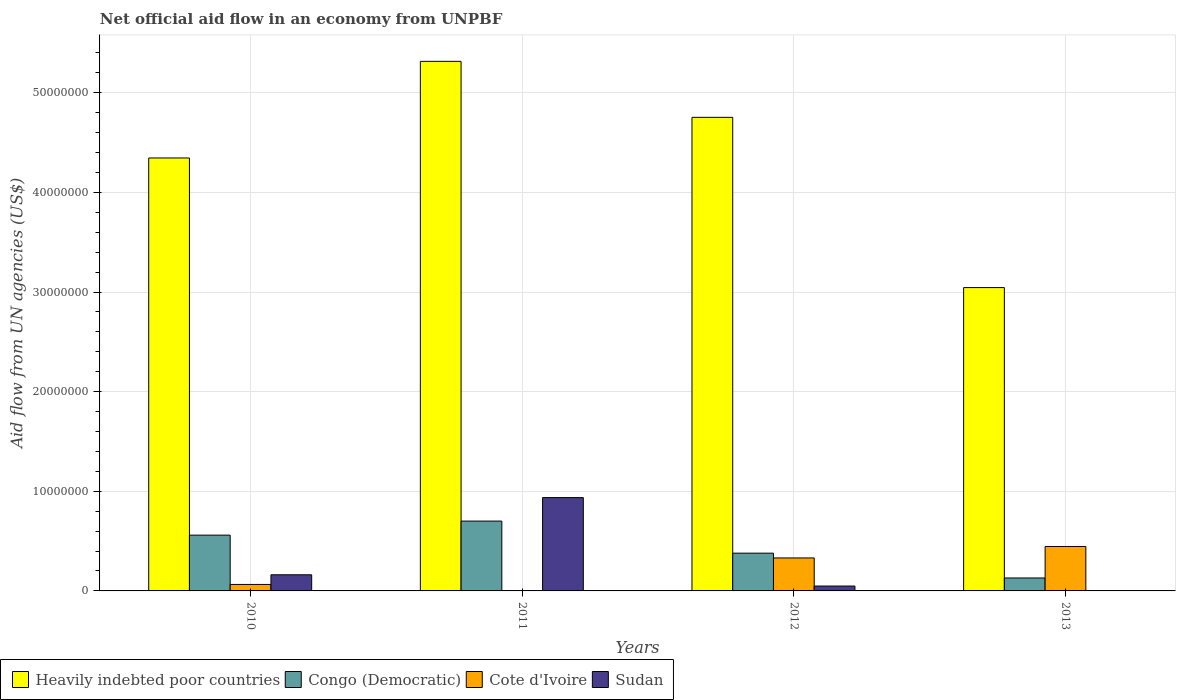How many groups of bars are there?
Keep it short and to the point. 4. Are the number of bars per tick equal to the number of legend labels?
Keep it short and to the point. No. In how many cases, is the number of bars for a given year not equal to the number of legend labels?
Offer a very short reply. 1. What is the net official aid flow in Heavily indebted poor countries in 2011?
Your response must be concise. 5.32e+07. Across all years, what is the maximum net official aid flow in Heavily indebted poor countries?
Ensure brevity in your answer.  5.32e+07. Across all years, what is the minimum net official aid flow in Cote d'Ivoire?
Ensure brevity in your answer.  3.00e+04. In which year was the net official aid flow in Congo (Democratic) maximum?
Keep it short and to the point. 2011. What is the total net official aid flow in Sudan in the graph?
Provide a succinct answer. 1.15e+07. What is the difference between the net official aid flow in Sudan in 2010 and that in 2011?
Give a very brief answer. -7.75e+06. What is the difference between the net official aid flow in Congo (Democratic) in 2011 and the net official aid flow in Sudan in 2010?
Your response must be concise. 5.39e+06. What is the average net official aid flow in Heavily indebted poor countries per year?
Provide a succinct answer. 4.37e+07. In the year 2011, what is the difference between the net official aid flow in Congo (Democratic) and net official aid flow in Sudan?
Your answer should be very brief. -2.36e+06. What is the ratio of the net official aid flow in Heavily indebted poor countries in 2011 to that in 2012?
Provide a short and direct response. 1.12. What is the difference between the highest and the second highest net official aid flow in Congo (Democratic)?
Make the answer very short. 1.41e+06. What is the difference between the highest and the lowest net official aid flow in Heavily indebted poor countries?
Keep it short and to the point. 2.27e+07. In how many years, is the net official aid flow in Sudan greater than the average net official aid flow in Sudan taken over all years?
Your answer should be very brief. 1. Is it the case that in every year, the sum of the net official aid flow in Heavily indebted poor countries and net official aid flow in Sudan is greater than the sum of net official aid flow in Congo (Democratic) and net official aid flow in Cote d'Ivoire?
Provide a succinct answer. Yes. Is it the case that in every year, the sum of the net official aid flow in Sudan and net official aid flow in Congo (Democratic) is greater than the net official aid flow in Heavily indebted poor countries?
Offer a terse response. No. How many bars are there?
Offer a very short reply. 15. How many years are there in the graph?
Ensure brevity in your answer.  4. What is the difference between two consecutive major ticks on the Y-axis?
Your answer should be very brief. 1.00e+07. Are the values on the major ticks of Y-axis written in scientific E-notation?
Give a very brief answer. No. Does the graph contain any zero values?
Offer a very short reply. Yes. What is the title of the graph?
Your answer should be compact. Net official aid flow in an economy from UNPBF. What is the label or title of the X-axis?
Your answer should be very brief. Years. What is the label or title of the Y-axis?
Your answer should be very brief. Aid flow from UN agencies (US$). What is the Aid flow from UN agencies (US$) in Heavily indebted poor countries in 2010?
Offer a very short reply. 4.35e+07. What is the Aid flow from UN agencies (US$) in Congo (Democratic) in 2010?
Offer a terse response. 5.60e+06. What is the Aid flow from UN agencies (US$) in Cote d'Ivoire in 2010?
Give a very brief answer. 6.50e+05. What is the Aid flow from UN agencies (US$) in Sudan in 2010?
Give a very brief answer. 1.62e+06. What is the Aid flow from UN agencies (US$) in Heavily indebted poor countries in 2011?
Make the answer very short. 5.32e+07. What is the Aid flow from UN agencies (US$) of Congo (Democratic) in 2011?
Ensure brevity in your answer.  7.01e+06. What is the Aid flow from UN agencies (US$) in Cote d'Ivoire in 2011?
Your answer should be compact. 3.00e+04. What is the Aid flow from UN agencies (US$) of Sudan in 2011?
Provide a succinct answer. 9.37e+06. What is the Aid flow from UN agencies (US$) of Heavily indebted poor countries in 2012?
Make the answer very short. 4.75e+07. What is the Aid flow from UN agencies (US$) of Congo (Democratic) in 2012?
Give a very brief answer. 3.79e+06. What is the Aid flow from UN agencies (US$) in Cote d'Ivoire in 2012?
Your answer should be very brief. 3.31e+06. What is the Aid flow from UN agencies (US$) of Sudan in 2012?
Offer a very short reply. 4.90e+05. What is the Aid flow from UN agencies (US$) in Heavily indebted poor countries in 2013?
Ensure brevity in your answer.  3.04e+07. What is the Aid flow from UN agencies (US$) of Congo (Democratic) in 2013?
Provide a short and direct response. 1.30e+06. What is the Aid flow from UN agencies (US$) of Cote d'Ivoire in 2013?
Make the answer very short. 4.46e+06. What is the Aid flow from UN agencies (US$) in Sudan in 2013?
Give a very brief answer. 0. Across all years, what is the maximum Aid flow from UN agencies (US$) in Heavily indebted poor countries?
Provide a short and direct response. 5.32e+07. Across all years, what is the maximum Aid flow from UN agencies (US$) in Congo (Democratic)?
Keep it short and to the point. 7.01e+06. Across all years, what is the maximum Aid flow from UN agencies (US$) of Cote d'Ivoire?
Offer a very short reply. 4.46e+06. Across all years, what is the maximum Aid flow from UN agencies (US$) in Sudan?
Provide a succinct answer. 9.37e+06. Across all years, what is the minimum Aid flow from UN agencies (US$) in Heavily indebted poor countries?
Give a very brief answer. 3.04e+07. Across all years, what is the minimum Aid flow from UN agencies (US$) of Congo (Democratic)?
Ensure brevity in your answer.  1.30e+06. Across all years, what is the minimum Aid flow from UN agencies (US$) of Sudan?
Your response must be concise. 0. What is the total Aid flow from UN agencies (US$) of Heavily indebted poor countries in the graph?
Your answer should be compact. 1.75e+08. What is the total Aid flow from UN agencies (US$) in Congo (Democratic) in the graph?
Offer a terse response. 1.77e+07. What is the total Aid flow from UN agencies (US$) in Cote d'Ivoire in the graph?
Give a very brief answer. 8.45e+06. What is the total Aid flow from UN agencies (US$) in Sudan in the graph?
Make the answer very short. 1.15e+07. What is the difference between the Aid flow from UN agencies (US$) of Heavily indebted poor countries in 2010 and that in 2011?
Make the answer very short. -9.70e+06. What is the difference between the Aid flow from UN agencies (US$) in Congo (Democratic) in 2010 and that in 2011?
Ensure brevity in your answer.  -1.41e+06. What is the difference between the Aid flow from UN agencies (US$) in Cote d'Ivoire in 2010 and that in 2011?
Your answer should be compact. 6.20e+05. What is the difference between the Aid flow from UN agencies (US$) of Sudan in 2010 and that in 2011?
Your response must be concise. -7.75e+06. What is the difference between the Aid flow from UN agencies (US$) of Heavily indebted poor countries in 2010 and that in 2012?
Make the answer very short. -4.08e+06. What is the difference between the Aid flow from UN agencies (US$) of Congo (Democratic) in 2010 and that in 2012?
Offer a very short reply. 1.81e+06. What is the difference between the Aid flow from UN agencies (US$) of Cote d'Ivoire in 2010 and that in 2012?
Provide a short and direct response. -2.66e+06. What is the difference between the Aid flow from UN agencies (US$) in Sudan in 2010 and that in 2012?
Make the answer very short. 1.13e+06. What is the difference between the Aid flow from UN agencies (US$) of Heavily indebted poor countries in 2010 and that in 2013?
Make the answer very short. 1.30e+07. What is the difference between the Aid flow from UN agencies (US$) in Congo (Democratic) in 2010 and that in 2013?
Keep it short and to the point. 4.30e+06. What is the difference between the Aid flow from UN agencies (US$) in Cote d'Ivoire in 2010 and that in 2013?
Your response must be concise. -3.81e+06. What is the difference between the Aid flow from UN agencies (US$) in Heavily indebted poor countries in 2011 and that in 2012?
Your response must be concise. 5.62e+06. What is the difference between the Aid flow from UN agencies (US$) of Congo (Democratic) in 2011 and that in 2012?
Your answer should be very brief. 3.22e+06. What is the difference between the Aid flow from UN agencies (US$) in Cote d'Ivoire in 2011 and that in 2012?
Keep it short and to the point. -3.28e+06. What is the difference between the Aid flow from UN agencies (US$) of Sudan in 2011 and that in 2012?
Offer a very short reply. 8.88e+06. What is the difference between the Aid flow from UN agencies (US$) in Heavily indebted poor countries in 2011 and that in 2013?
Offer a terse response. 2.27e+07. What is the difference between the Aid flow from UN agencies (US$) in Congo (Democratic) in 2011 and that in 2013?
Ensure brevity in your answer.  5.71e+06. What is the difference between the Aid flow from UN agencies (US$) in Cote d'Ivoire in 2011 and that in 2013?
Your answer should be very brief. -4.43e+06. What is the difference between the Aid flow from UN agencies (US$) of Heavily indebted poor countries in 2012 and that in 2013?
Keep it short and to the point. 1.71e+07. What is the difference between the Aid flow from UN agencies (US$) of Congo (Democratic) in 2012 and that in 2013?
Your response must be concise. 2.49e+06. What is the difference between the Aid flow from UN agencies (US$) of Cote d'Ivoire in 2012 and that in 2013?
Keep it short and to the point. -1.15e+06. What is the difference between the Aid flow from UN agencies (US$) in Heavily indebted poor countries in 2010 and the Aid flow from UN agencies (US$) in Congo (Democratic) in 2011?
Ensure brevity in your answer.  3.64e+07. What is the difference between the Aid flow from UN agencies (US$) of Heavily indebted poor countries in 2010 and the Aid flow from UN agencies (US$) of Cote d'Ivoire in 2011?
Your answer should be compact. 4.34e+07. What is the difference between the Aid flow from UN agencies (US$) in Heavily indebted poor countries in 2010 and the Aid flow from UN agencies (US$) in Sudan in 2011?
Ensure brevity in your answer.  3.41e+07. What is the difference between the Aid flow from UN agencies (US$) in Congo (Democratic) in 2010 and the Aid flow from UN agencies (US$) in Cote d'Ivoire in 2011?
Offer a very short reply. 5.57e+06. What is the difference between the Aid flow from UN agencies (US$) of Congo (Democratic) in 2010 and the Aid flow from UN agencies (US$) of Sudan in 2011?
Give a very brief answer. -3.77e+06. What is the difference between the Aid flow from UN agencies (US$) in Cote d'Ivoire in 2010 and the Aid flow from UN agencies (US$) in Sudan in 2011?
Your answer should be very brief. -8.72e+06. What is the difference between the Aid flow from UN agencies (US$) in Heavily indebted poor countries in 2010 and the Aid flow from UN agencies (US$) in Congo (Democratic) in 2012?
Ensure brevity in your answer.  3.97e+07. What is the difference between the Aid flow from UN agencies (US$) in Heavily indebted poor countries in 2010 and the Aid flow from UN agencies (US$) in Cote d'Ivoire in 2012?
Keep it short and to the point. 4.02e+07. What is the difference between the Aid flow from UN agencies (US$) of Heavily indebted poor countries in 2010 and the Aid flow from UN agencies (US$) of Sudan in 2012?
Your response must be concise. 4.30e+07. What is the difference between the Aid flow from UN agencies (US$) in Congo (Democratic) in 2010 and the Aid flow from UN agencies (US$) in Cote d'Ivoire in 2012?
Keep it short and to the point. 2.29e+06. What is the difference between the Aid flow from UN agencies (US$) in Congo (Democratic) in 2010 and the Aid flow from UN agencies (US$) in Sudan in 2012?
Ensure brevity in your answer.  5.11e+06. What is the difference between the Aid flow from UN agencies (US$) in Cote d'Ivoire in 2010 and the Aid flow from UN agencies (US$) in Sudan in 2012?
Ensure brevity in your answer.  1.60e+05. What is the difference between the Aid flow from UN agencies (US$) of Heavily indebted poor countries in 2010 and the Aid flow from UN agencies (US$) of Congo (Democratic) in 2013?
Your answer should be very brief. 4.22e+07. What is the difference between the Aid flow from UN agencies (US$) in Heavily indebted poor countries in 2010 and the Aid flow from UN agencies (US$) in Cote d'Ivoire in 2013?
Make the answer very short. 3.90e+07. What is the difference between the Aid flow from UN agencies (US$) of Congo (Democratic) in 2010 and the Aid flow from UN agencies (US$) of Cote d'Ivoire in 2013?
Give a very brief answer. 1.14e+06. What is the difference between the Aid flow from UN agencies (US$) of Heavily indebted poor countries in 2011 and the Aid flow from UN agencies (US$) of Congo (Democratic) in 2012?
Your response must be concise. 4.94e+07. What is the difference between the Aid flow from UN agencies (US$) of Heavily indebted poor countries in 2011 and the Aid flow from UN agencies (US$) of Cote d'Ivoire in 2012?
Provide a succinct answer. 4.98e+07. What is the difference between the Aid flow from UN agencies (US$) in Heavily indebted poor countries in 2011 and the Aid flow from UN agencies (US$) in Sudan in 2012?
Make the answer very short. 5.27e+07. What is the difference between the Aid flow from UN agencies (US$) of Congo (Democratic) in 2011 and the Aid flow from UN agencies (US$) of Cote d'Ivoire in 2012?
Your answer should be compact. 3.70e+06. What is the difference between the Aid flow from UN agencies (US$) of Congo (Democratic) in 2011 and the Aid flow from UN agencies (US$) of Sudan in 2012?
Provide a succinct answer. 6.52e+06. What is the difference between the Aid flow from UN agencies (US$) in Cote d'Ivoire in 2011 and the Aid flow from UN agencies (US$) in Sudan in 2012?
Give a very brief answer. -4.60e+05. What is the difference between the Aid flow from UN agencies (US$) in Heavily indebted poor countries in 2011 and the Aid flow from UN agencies (US$) in Congo (Democratic) in 2013?
Keep it short and to the point. 5.19e+07. What is the difference between the Aid flow from UN agencies (US$) of Heavily indebted poor countries in 2011 and the Aid flow from UN agencies (US$) of Cote d'Ivoire in 2013?
Provide a short and direct response. 4.87e+07. What is the difference between the Aid flow from UN agencies (US$) in Congo (Democratic) in 2011 and the Aid flow from UN agencies (US$) in Cote d'Ivoire in 2013?
Make the answer very short. 2.55e+06. What is the difference between the Aid flow from UN agencies (US$) of Heavily indebted poor countries in 2012 and the Aid flow from UN agencies (US$) of Congo (Democratic) in 2013?
Keep it short and to the point. 4.62e+07. What is the difference between the Aid flow from UN agencies (US$) of Heavily indebted poor countries in 2012 and the Aid flow from UN agencies (US$) of Cote d'Ivoire in 2013?
Offer a very short reply. 4.31e+07. What is the difference between the Aid flow from UN agencies (US$) of Congo (Democratic) in 2012 and the Aid flow from UN agencies (US$) of Cote d'Ivoire in 2013?
Your answer should be compact. -6.70e+05. What is the average Aid flow from UN agencies (US$) of Heavily indebted poor countries per year?
Your answer should be compact. 4.37e+07. What is the average Aid flow from UN agencies (US$) in Congo (Democratic) per year?
Provide a succinct answer. 4.42e+06. What is the average Aid flow from UN agencies (US$) in Cote d'Ivoire per year?
Provide a succinct answer. 2.11e+06. What is the average Aid flow from UN agencies (US$) in Sudan per year?
Your answer should be very brief. 2.87e+06. In the year 2010, what is the difference between the Aid flow from UN agencies (US$) in Heavily indebted poor countries and Aid flow from UN agencies (US$) in Congo (Democratic)?
Offer a very short reply. 3.79e+07. In the year 2010, what is the difference between the Aid flow from UN agencies (US$) in Heavily indebted poor countries and Aid flow from UN agencies (US$) in Cote d'Ivoire?
Give a very brief answer. 4.28e+07. In the year 2010, what is the difference between the Aid flow from UN agencies (US$) in Heavily indebted poor countries and Aid flow from UN agencies (US$) in Sudan?
Your answer should be very brief. 4.18e+07. In the year 2010, what is the difference between the Aid flow from UN agencies (US$) in Congo (Democratic) and Aid flow from UN agencies (US$) in Cote d'Ivoire?
Offer a very short reply. 4.95e+06. In the year 2010, what is the difference between the Aid flow from UN agencies (US$) in Congo (Democratic) and Aid flow from UN agencies (US$) in Sudan?
Make the answer very short. 3.98e+06. In the year 2010, what is the difference between the Aid flow from UN agencies (US$) of Cote d'Ivoire and Aid flow from UN agencies (US$) of Sudan?
Your answer should be very brief. -9.70e+05. In the year 2011, what is the difference between the Aid flow from UN agencies (US$) in Heavily indebted poor countries and Aid flow from UN agencies (US$) in Congo (Democratic)?
Make the answer very short. 4.62e+07. In the year 2011, what is the difference between the Aid flow from UN agencies (US$) of Heavily indebted poor countries and Aid flow from UN agencies (US$) of Cote d'Ivoire?
Keep it short and to the point. 5.31e+07. In the year 2011, what is the difference between the Aid flow from UN agencies (US$) in Heavily indebted poor countries and Aid flow from UN agencies (US$) in Sudan?
Ensure brevity in your answer.  4.38e+07. In the year 2011, what is the difference between the Aid flow from UN agencies (US$) of Congo (Democratic) and Aid flow from UN agencies (US$) of Cote d'Ivoire?
Offer a very short reply. 6.98e+06. In the year 2011, what is the difference between the Aid flow from UN agencies (US$) of Congo (Democratic) and Aid flow from UN agencies (US$) of Sudan?
Provide a succinct answer. -2.36e+06. In the year 2011, what is the difference between the Aid flow from UN agencies (US$) of Cote d'Ivoire and Aid flow from UN agencies (US$) of Sudan?
Your answer should be very brief. -9.34e+06. In the year 2012, what is the difference between the Aid flow from UN agencies (US$) of Heavily indebted poor countries and Aid flow from UN agencies (US$) of Congo (Democratic)?
Offer a very short reply. 4.38e+07. In the year 2012, what is the difference between the Aid flow from UN agencies (US$) in Heavily indebted poor countries and Aid flow from UN agencies (US$) in Cote d'Ivoire?
Offer a terse response. 4.42e+07. In the year 2012, what is the difference between the Aid flow from UN agencies (US$) in Heavily indebted poor countries and Aid flow from UN agencies (US$) in Sudan?
Your answer should be compact. 4.70e+07. In the year 2012, what is the difference between the Aid flow from UN agencies (US$) of Congo (Democratic) and Aid flow from UN agencies (US$) of Cote d'Ivoire?
Your answer should be very brief. 4.80e+05. In the year 2012, what is the difference between the Aid flow from UN agencies (US$) of Congo (Democratic) and Aid flow from UN agencies (US$) of Sudan?
Provide a short and direct response. 3.30e+06. In the year 2012, what is the difference between the Aid flow from UN agencies (US$) in Cote d'Ivoire and Aid flow from UN agencies (US$) in Sudan?
Your answer should be compact. 2.82e+06. In the year 2013, what is the difference between the Aid flow from UN agencies (US$) of Heavily indebted poor countries and Aid flow from UN agencies (US$) of Congo (Democratic)?
Keep it short and to the point. 2.92e+07. In the year 2013, what is the difference between the Aid flow from UN agencies (US$) of Heavily indebted poor countries and Aid flow from UN agencies (US$) of Cote d'Ivoire?
Your answer should be compact. 2.60e+07. In the year 2013, what is the difference between the Aid flow from UN agencies (US$) of Congo (Democratic) and Aid flow from UN agencies (US$) of Cote d'Ivoire?
Offer a very short reply. -3.16e+06. What is the ratio of the Aid flow from UN agencies (US$) of Heavily indebted poor countries in 2010 to that in 2011?
Ensure brevity in your answer.  0.82. What is the ratio of the Aid flow from UN agencies (US$) of Congo (Democratic) in 2010 to that in 2011?
Offer a very short reply. 0.8. What is the ratio of the Aid flow from UN agencies (US$) of Cote d'Ivoire in 2010 to that in 2011?
Ensure brevity in your answer.  21.67. What is the ratio of the Aid flow from UN agencies (US$) in Sudan in 2010 to that in 2011?
Your response must be concise. 0.17. What is the ratio of the Aid flow from UN agencies (US$) in Heavily indebted poor countries in 2010 to that in 2012?
Make the answer very short. 0.91. What is the ratio of the Aid flow from UN agencies (US$) of Congo (Democratic) in 2010 to that in 2012?
Make the answer very short. 1.48. What is the ratio of the Aid flow from UN agencies (US$) of Cote d'Ivoire in 2010 to that in 2012?
Offer a very short reply. 0.2. What is the ratio of the Aid flow from UN agencies (US$) of Sudan in 2010 to that in 2012?
Your answer should be compact. 3.31. What is the ratio of the Aid flow from UN agencies (US$) of Heavily indebted poor countries in 2010 to that in 2013?
Give a very brief answer. 1.43. What is the ratio of the Aid flow from UN agencies (US$) of Congo (Democratic) in 2010 to that in 2013?
Offer a very short reply. 4.31. What is the ratio of the Aid flow from UN agencies (US$) of Cote d'Ivoire in 2010 to that in 2013?
Your answer should be very brief. 0.15. What is the ratio of the Aid flow from UN agencies (US$) of Heavily indebted poor countries in 2011 to that in 2012?
Offer a very short reply. 1.12. What is the ratio of the Aid flow from UN agencies (US$) of Congo (Democratic) in 2011 to that in 2012?
Make the answer very short. 1.85. What is the ratio of the Aid flow from UN agencies (US$) of Cote d'Ivoire in 2011 to that in 2012?
Your response must be concise. 0.01. What is the ratio of the Aid flow from UN agencies (US$) in Sudan in 2011 to that in 2012?
Offer a terse response. 19.12. What is the ratio of the Aid flow from UN agencies (US$) of Heavily indebted poor countries in 2011 to that in 2013?
Make the answer very short. 1.75. What is the ratio of the Aid flow from UN agencies (US$) in Congo (Democratic) in 2011 to that in 2013?
Keep it short and to the point. 5.39. What is the ratio of the Aid flow from UN agencies (US$) of Cote d'Ivoire in 2011 to that in 2013?
Offer a very short reply. 0.01. What is the ratio of the Aid flow from UN agencies (US$) of Heavily indebted poor countries in 2012 to that in 2013?
Your response must be concise. 1.56. What is the ratio of the Aid flow from UN agencies (US$) in Congo (Democratic) in 2012 to that in 2013?
Your answer should be compact. 2.92. What is the ratio of the Aid flow from UN agencies (US$) of Cote d'Ivoire in 2012 to that in 2013?
Offer a very short reply. 0.74. What is the difference between the highest and the second highest Aid flow from UN agencies (US$) of Heavily indebted poor countries?
Offer a terse response. 5.62e+06. What is the difference between the highest and the second highest Aid flow from UN agencies (US$) in Congo (Democratic)?
Give a very brief answer. 1.41e+06. What is the difference between the highest and the second highest Aid flow from UN agencies (US$) in Cote d'Ivoire?
Your answer should be very brief. 1.15e+06. What is the difference between the highest and the second highest Aid flow from UN agencies (US$) in Sudan?
Your answer should be very brief. 7.75e+06. What is the difference between the highest and the lowest Aid flow from UN agencies (US$) of Heavily indebted poor countries?
Your response must be concise. 2.27e+07. What is the difference between the highest and the lowest Aid flow from UN agencies (US$) in Congo (Democratic)?
Your answer should be compact. 5.71e+06. What is the difference between the highest and the lowest Aid flow from UN agencies (US$) of Cote d'Ivoire?
Your response must be concise. 4.43e+06. What is the difference between the highest and the lowest Aid flow from UN agencies (US$) in Sudan?
Your response must be concise. 9.37e+06. 